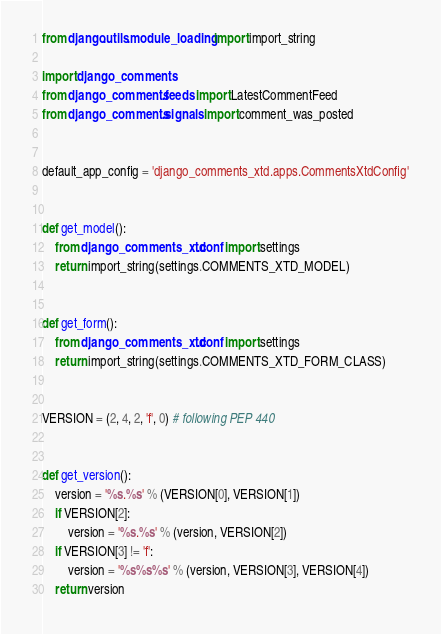<code> <loc_0><loc_0><loc_500><loc_500><_Python_>from django.utils.module_loading import import_string
    
import django_comments
from django_comments.feeds import LatestCommentFeed
from django_comments.signals import comment_was_posted


default_app_config = 'django_comments_xtd.apps.CommentsXtdConfig'


def get_model():
    from django_comments_xtd.conf import settings
    return import_string(settings.COMMENTS_XTD_MODEL)


def get_form():
    from django_comments_xtd.conf import settings
    return import_string(settings.COMMENTS_XTD_FORM_CLASS)


VERSION = (2, 4, 2, 'f', 0) # following PEP 440


def get_version():
    version = '%s.%s' % (VERSION[0], VERSION[1])
    if VERSION[2]:
        version = '%s.%s' % (version, VERSION[2])
    if VERSION[3] != 'f':
        version = '%s%s%s' % (version, VERSION[3], VERSION[4])
    return version
</code> 